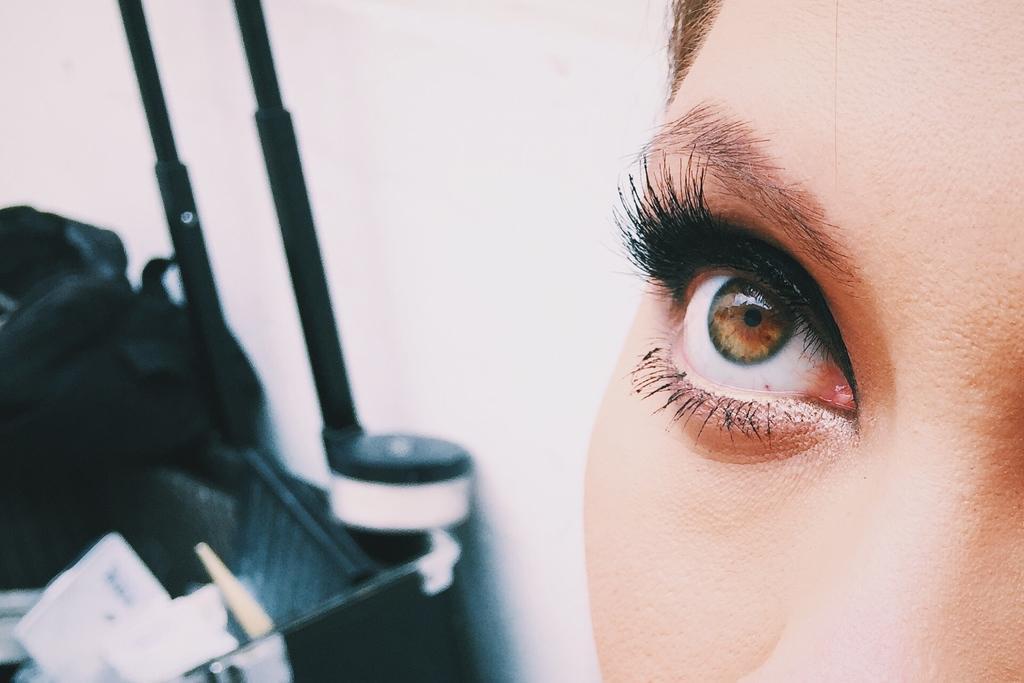Could you give a brief overview of what you see in this image? In the foreground of this image, on the right, there is an eye, forehead and cheek of a person. In the background, there is a wall and few black objects. 